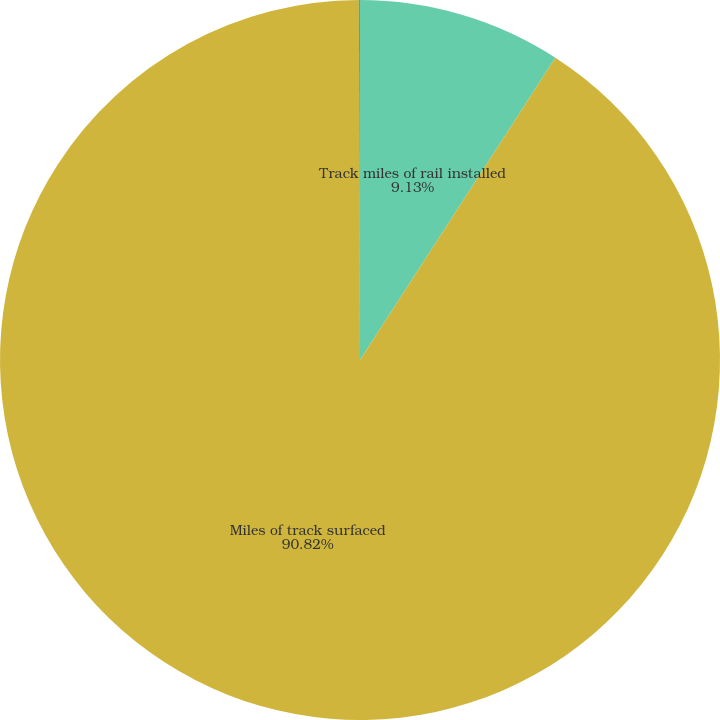Convert chart. <chart><loc_0><loc_0><loc_500><loc_500><pie_chart><fcel>Track miles of rail installed<fcel>Miles of track surfaced<fcel>New crossties installed<nl><fcel>9.13%<fcel>90.82%<fcel>0.05%<nl></chart> 